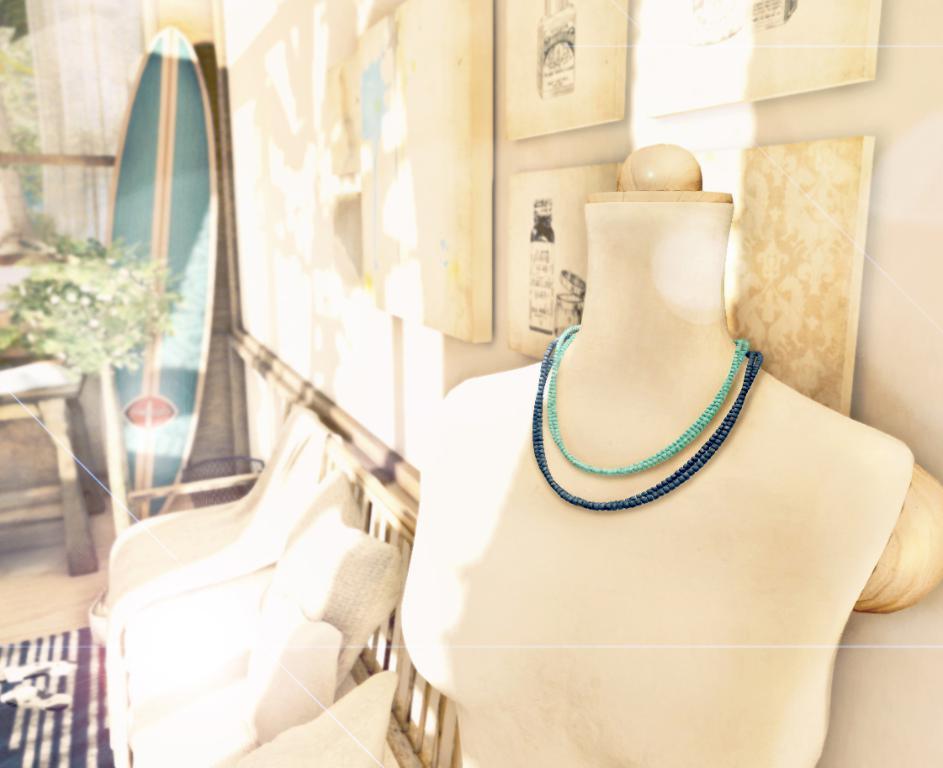Could you give a brief overview of what you see in this image? In this image, we can see some necklaces on the necklace holder. We can see the sofa and the ground with some objects. We can also see the wall with some posters and objects. We can see a table. 